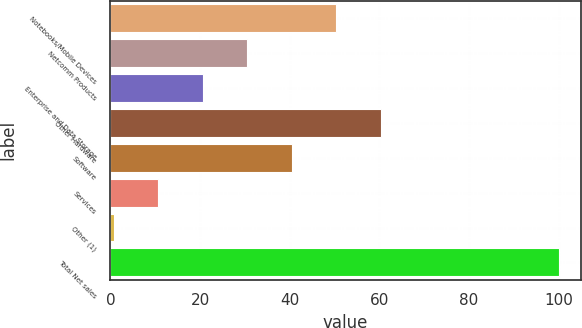Convert chart to OTSL. <chart><loc_0><loc_0><loc_500><loc_500><bar_chart><fcel>Notebooks/Mobile Devices<fcel>Netcomm Products<fcel>Enterprise and Data Storage<fcel>Other Hardware<fcel>Software<fcel>Services<fcel>Other (1)<fcel>Total Net sales<nl><fcel>50.4<fcel>30.56<fcel>20.64<fcel>60.32<fcel>40.48<fcel>10.72<fcel>0.8<fcel>100<nl></chart> 